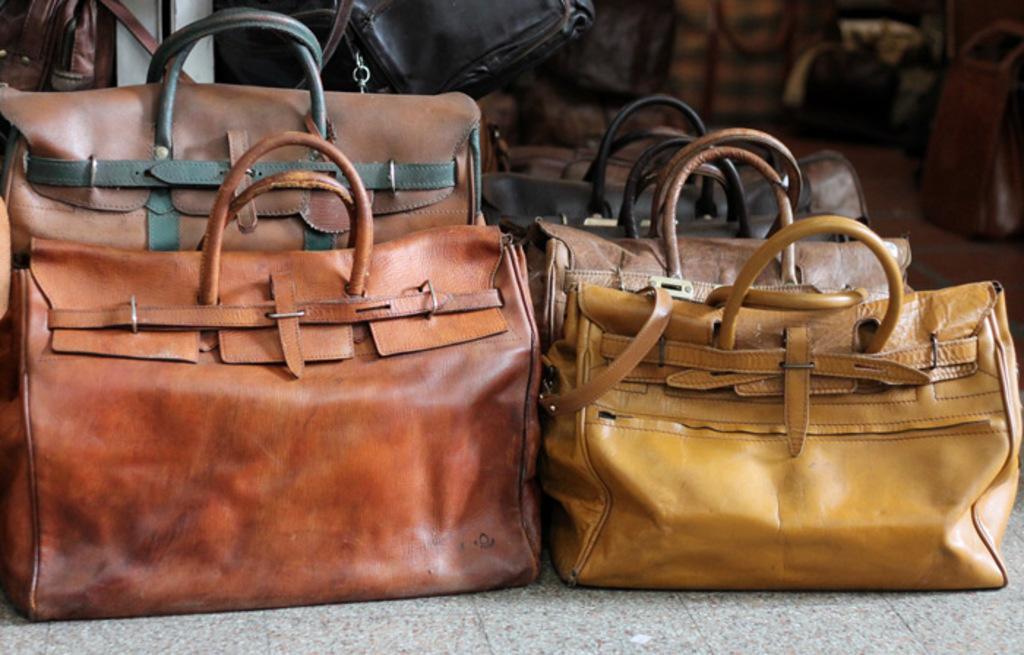Describe this image in one or two sentences. This is the picture of a brown color leather hand bag in the background there are group of handbags. 